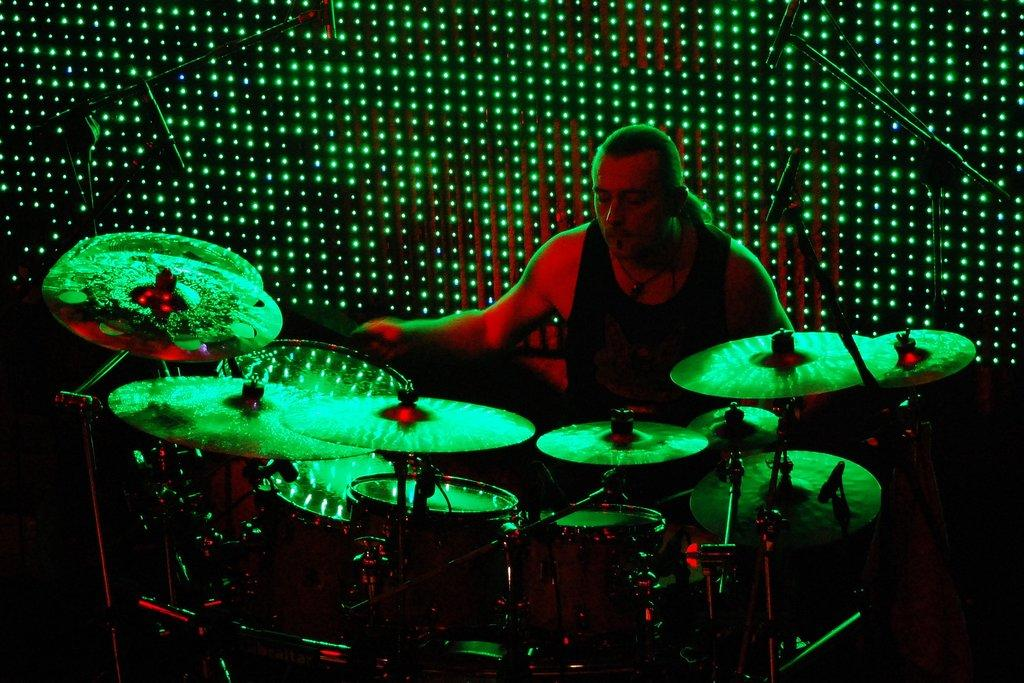What is the man in the image doing? The man is sitting in the image. What else can be seen in the image besides the man? There are musical instruments and microphones in the image. What can be seen in the background of the image? There are lights visible in the background of the image. Where is the girl sitting with the branch and thread in the image? There is no girl, branch, or thread present in the image. 